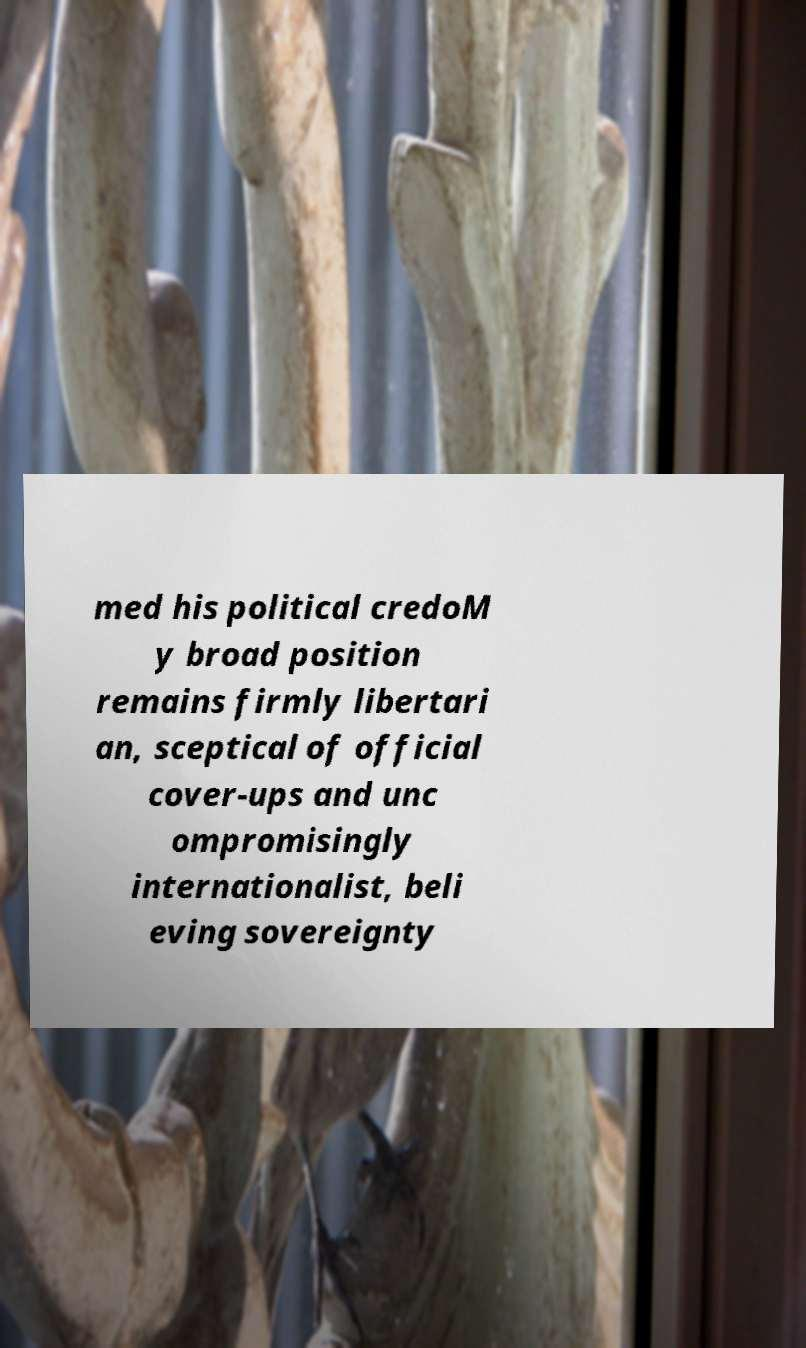There's text embedded in this image that I need extracted. Can you transcribe it verbatim? med his political credoM y broad position remains firmly libertari an, sceptical of official cover-ups and unc ompromisingly internationalist, beli eving sovereignty 